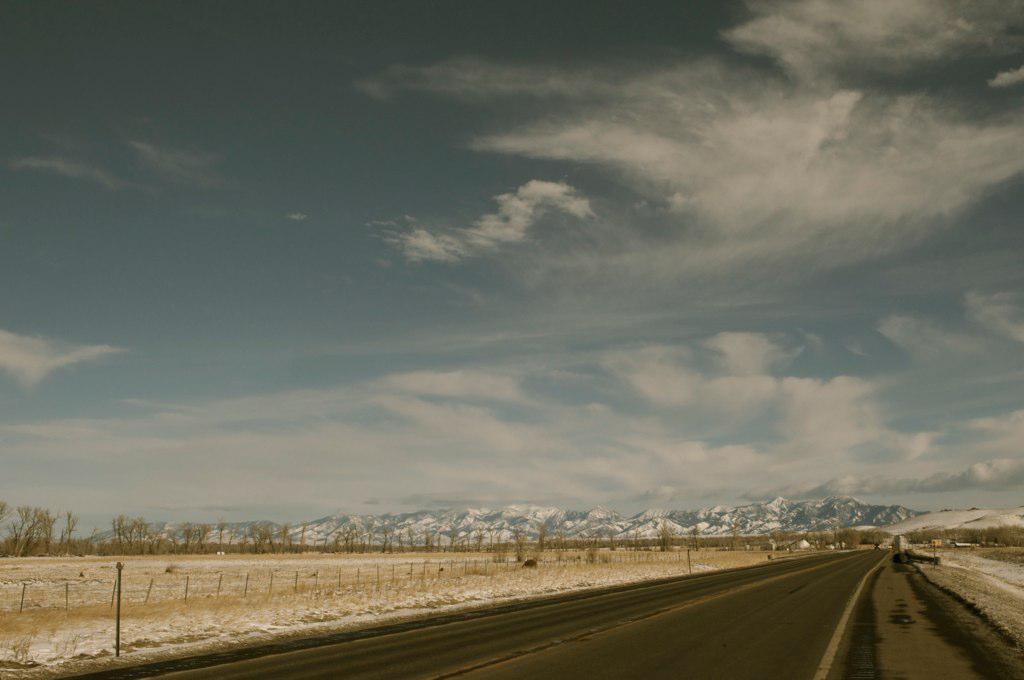In one or two sentences, can you explain what this image depicts? In this image we can see the road, cement fencing poles, we can see the dried trees, hills with snow, at the top we can see the sky with clouds. 